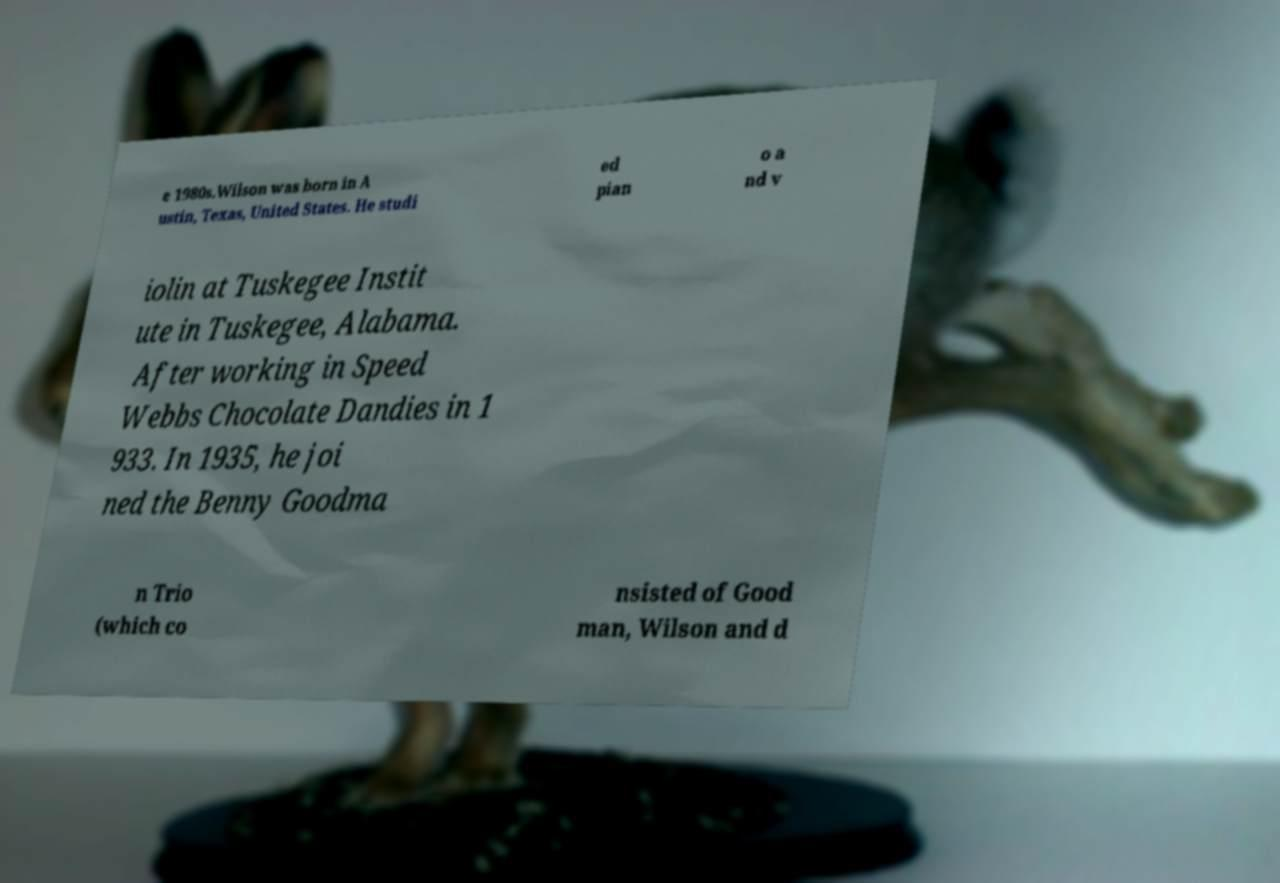Please read and relay the text visible in this image. What does it say? e 1980s.Wilson was born in A ustin, Texas, United States. He studi ed pian o a nd v iolin at Tuskegee Instit ute in Tuskegee, Alabama. After working in Speed Webbs Chocolate Dandies in 1 933. In 1935, he joi ned the Benny Goodma n Trio (which co nsisted of Good man, Wilson and d 